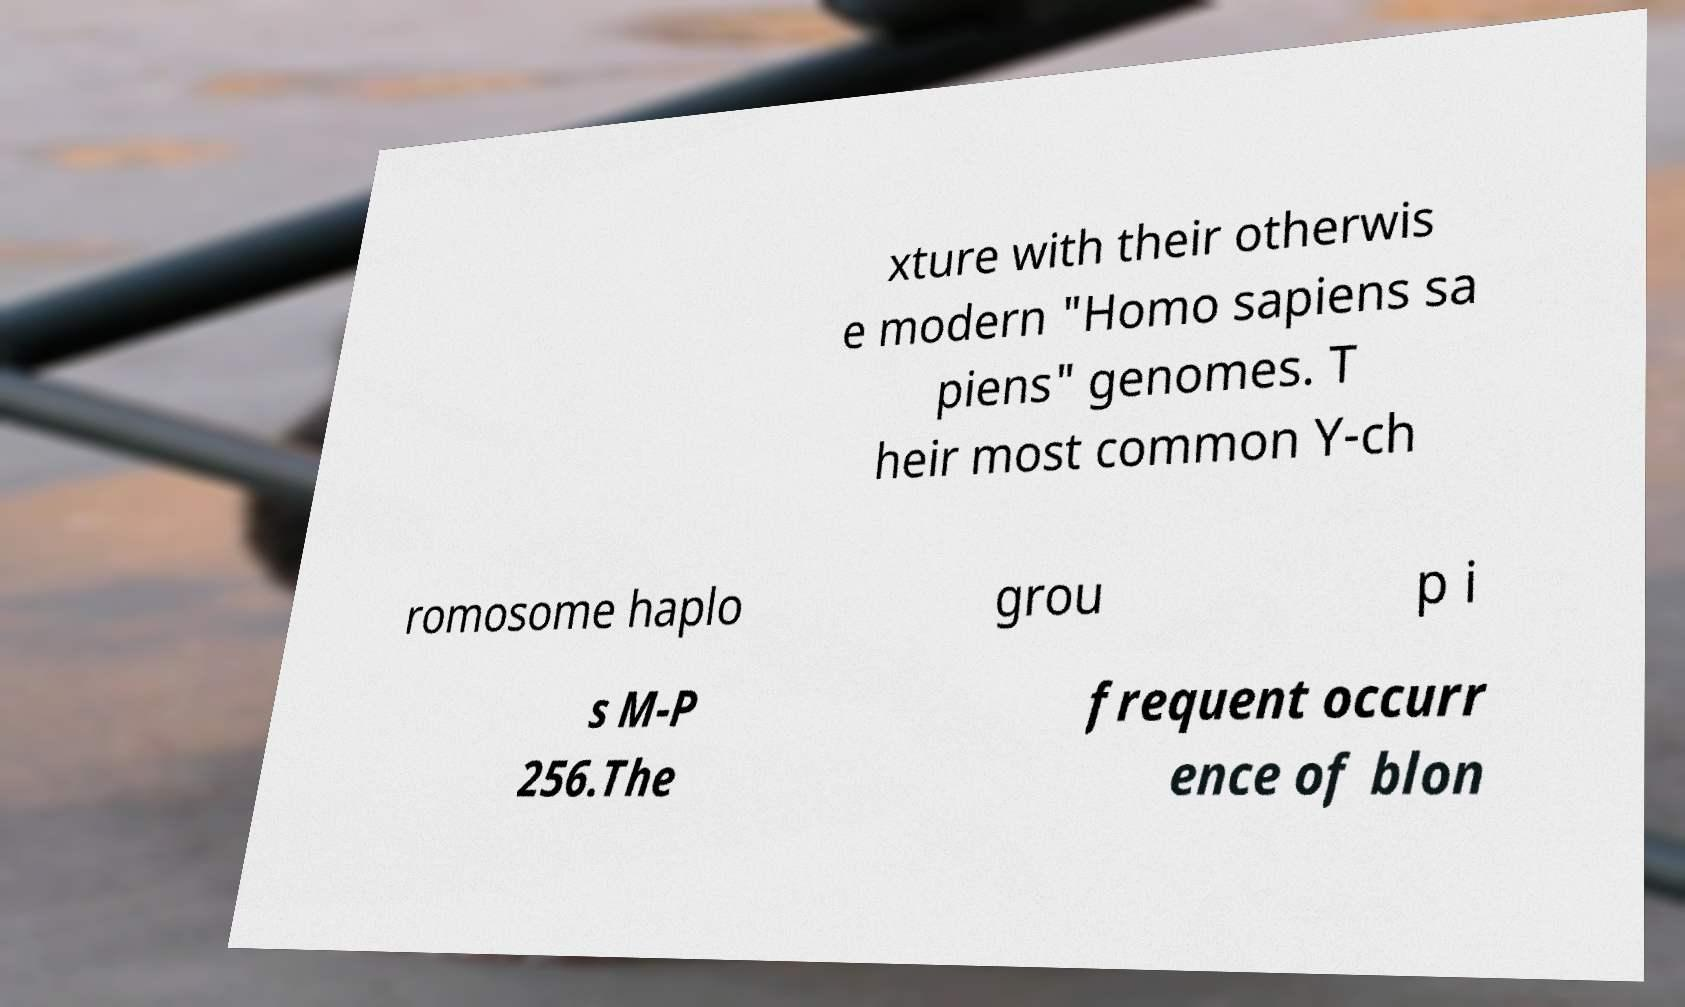There's text embedded in this image that I need extracted. Can you transcribe it verbatim? xture with their otherwis e modern "Homo sapiens sa piens" genomes. T heir most common Y-ch romosome haplo grou p i s M-P 256.The frequent occurr ence of blon 